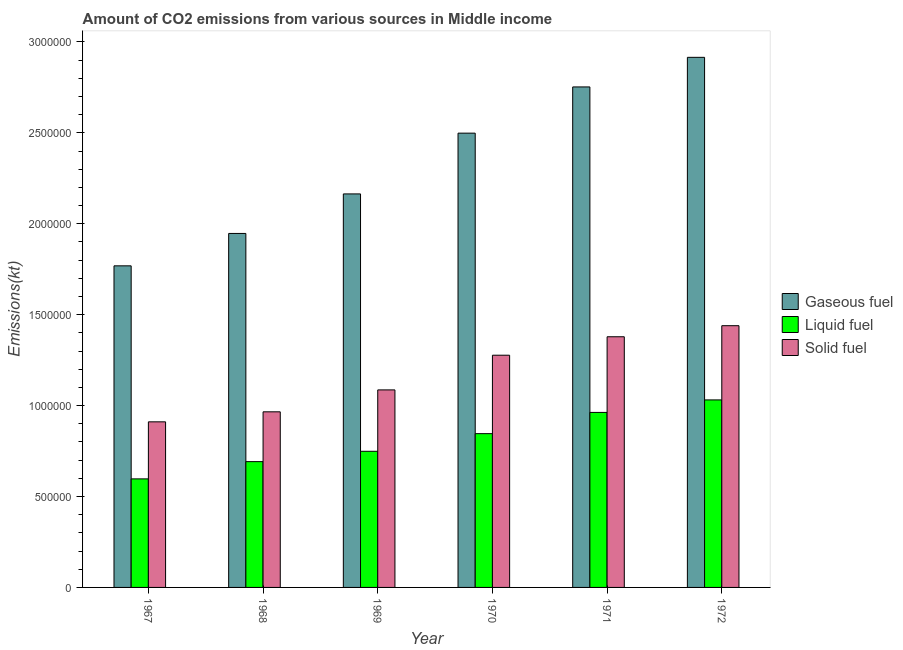How many bars are there on the 3rd tick from the left?
Make the answer very short. 3. How many bars are there on the 4th tick from the right?
Offer a terse response. 3. What is the label of the 1st group of bars from the left?
Your response must be concise. 1967. What is the amount of co2 emissions from liquid fuel in 1968?
Keep it short and to the point. 6.92e+05. Across all years, what is the maximum amount of co2 emissions from gaseous fuel?
Keep it short and to the point. 2.92e+06. Across all years, what is the minimum amount of co2 emissions from gaseous fuel?
Your answer should be very brief. 1.77e+06. In which year was the amount of co2 emissions from gaseous fuel maximum?
Ensure brevity in your answer.  1972. In which year was the amount of co2 emissions from solid fuel minimum?
Make the answer very short. 1967. What is the total amount of co2 emissions from solid fuel in the graph?
Provide a succinct answer. 7.06e+06. What is the difference between the amount of co2 emissions from gaseous fuel in 1968 and that in 1969?
Keep it short and to the point. -2.17e+05. What is the difference between the amount of co2 emissions from solid fuel in 1968 and the amount of co2 emissions from gaseous fuel in 1972?
Provide a succinct answer. -4.74e+05. What is the average amount of co2 emissions from gaseous fuel per year?
Your answer should be very brief. 2.34e+06. In the year 1969, what is the difference between the amount of co2 emissions from solid fuel and amount of co2 emissions from liquid fuel?
Give a very brief answer. 0. In how many years, is the amount of co2 emissions from liquid fuel greater than 2800000 kt?
Your answer should be very brief. 0. What is the ratio of the amount of co2 emissions from solid fuel in 1967 to that in 1972?
Your response must be concise. 0.63. Is the amount of co2 emissions from solid fuel in 1967 less than that in 1972?
Keep it short and to the point. Yes. Is the difference between the amount of co2 emissions from gaseous fuel in 1967 and 1971 greater than the difference between the amount of co2 emissions from liquid fuel in 1967 and 1971?
Offer a terse response. No. What is the difference between the highest and the second highest amount of co2 emissions from liquid fuel?
Make the answer very short. 6.87e+04. What is the difference between the highest and the lowest amount of co2 emissions from liquid fuel?
Make the answer very short. 4.34e+05. Is the sum of the amount of co2 emissions from gaseous fuel in 1967 and 1972 greater than the maximum amount of co2 emissions from solid fuel across all years?
Your answer should be very brief. Yes. What does the 3rd bar from the left in 1969 represents?
Keep it short and to the point. Solid fuel. What does the 1st bar from the right in 1967 represents?
Your answer should be very brief. Solid fuel. Is it the case that in every year, the sum of the amount of co2 emissions from gaseous fuel and amount of co2 emissions from liquid fuel is greater than the amount of co2 emissions from solid fuel?
Make the answer very short. Yes. Are all the bars in the graph horizontal?
Your answer should be compact. No. Does the graph contain any zero values?
Ensure brevity in your answer.  No. Does the graph contain grids?
Give a very brief answer. No. Where does the legend appear in the graph?
Provide a succinct answer. Center right. How many legend labels are there?
Provide a succinct answer. 3. What is the title of the graph?
Ensure brevity in your answer.  Amount of CO2 emissions from various sources in Middle income. What is the label or title of the X-axis?
Offer a very short reply. Year. What is the label or title of the Y-axis?
Give a very brief answer. Emissions(kt). What is the Emissions(kt) of Gaseous fuel in 1967?
Keep it short and to the point. 1.77e+06. What is the Emissions(kt) in Liquid fuel in 1967?
Your answer should be compact. 5.97e+05. What is the Emissions(kt) in Solid fuel in 1967?
Ensure brevity in your answer.  9.11e+05. What is the Emissions(kt) in Gaseous fuel in 1968?
Your answer should be very brief. 1.95e+06. What is the Emissions(kt) of Liquid fuel in 1968?
Give a very brief answer. 6.92e+05. What is the Emissions(kt) of Solid fuel in 1968?
Offer a very short reply. 9.66e+05. What is the Emissions(kt) of Gaseous fuel in 1969?
Provide a short and direct response. 2.16e+06. What is the Emissions(kt) in Liquid fuel in 1969?
Make the answer very short. 7.49e+05. What is the Emissions(kt) in Solid fuel in 1969?
Provide a succinct answer. 1.09e+06. What is the Emissions(kt) of Gaseous fuel in 1970?
Provide a short and direct response. 2.50e+06. What is the Emissions(kt) of Liquid fuel in 1970?
Ensure brevity in your answer.  8.46e+05. What is the Emissions(kt) of Solid fuel in 1970?
Your answer should be compact. 1.28e+06. What is the Emissions(kt) of Gaseous fuel in 1971?
Your answer should be very brief. 2.75e+06. What is the Emissions(kt) in Liquid fuel in 1971?
Provide a succinct answer. 9.62e+05. What is the Emissions(kt) in Solid fuel in 1971?
Give a very brief answer. 1.38e+06. What is the Emissions(kt) of Gaseous fuel in 1972?
Offer a terse response. 2.92e+06. What is the Emissions(kt) of Liquid fuel in 1972?
Offer a very short reply. 1.03e+06. What is the Emissions(kt) of Solid fuel in 1972?
Give a very brief answer. 1.44e+06. Across all years, what is the maximum Emissions(kt) in Gaseous fuel?
Give a very brief answer. 2.92e+06. Across all years, what is the maximum Emissions(kt) of Liquid fuel?
Your answer should be compact. 1.03e+06. Across all years, what is the maximum Emissions(kt) in Solid fuel?
Give a very brief answer. 1.44e+06. Across all years, what is the minimum Emissions(kt) of Gaseous fuel?
Ensure brevity in your answer.  1.77e+06. Across all years, what is the minimum Emissions(kt) in Liquid fuel?
Offer a terse response. 5.97e+05. Across all years, what is the minimum Emissions(kt) in Solid fuel?
Your answer should be compact. 9.11e+05. What is the total Emissions(kt) in Gaseous fuel in the graph?
Provide a short and direct response. 1.40e+07. What is the total Emissions(kt) in Liquid fuel in the graph?
Your answer should be compact. 4.88e+06. What is the total Emissions(kt) of Solid fuel in the graph?
Keep it short and to the point. 7.06e+06. What is the difference between the Emissions(kt) of Gaseous fuel in 1967 and that in 1968?
Your answer should be very brief. -1.78e+05. What is the difference between the Emissions(kt) in Liquid fuel in 1967 and that in 1968?
Provide a succinct answer. -9.49e+04. What is the difference between the Emissions(kt) of Solid fuel in 1967 and that in 1968?
Ensure brevity in your answer.  -5.51e+04. What is the difference between the Emissions(kt) in Gaseous fuel in 1967 and that in 1969?
Your response must be concise. -3.95e+05. What is the difference between the Emissions(kt) in Liquid fuel in 1967 and that in 1969?
Your answer should be very brief. -1.52e+05. What is the difference between the Emissions(kt) of Solid fuel in 1967 and that in 1969?
Your response must be concise. -1.76e+05. What is the difference between the Emissions(kt) of Gaseous fuel in 1967 and that in 1970?
Your response must be concise. -7.30e+05. What is the difference between the Emissions(kt) of Liquid fuel in 1967 and that in 1970?
Ensure brevity in your answer.  -2.49e+05. What is the difference between the Emissions(kt) of Solid fuel in 1967 and that in 1970?
Your response must be concise. -3.66e+05. What is the difference between the Emissions(kt) of Gaseous fuel in 1967 and that in 1971?
Your response must be concise. -9.84e+05. What is the difference between the Emissions(kt) in Liquid fuel in 1967 and that in 1971?
Ensure brevity in your answer.  -3.66e+05. What is the difference between the Emissions(kt) in Solid fuel in 1967 and that in 1971?
Ensure brevity in your answer.  -4.68e+05. What is the difference between the Emissions(kt) of Gaseous fuel in 1967 and that in 1972?
Make the answer very short. -1.15e+06. What is the difference between the Emissions(kt) in Liquid fuel in 1967 and that in 1972?
Your response must be concise. -4.34e+05. What is the difference between the Emissions(kt) in Solid fuel in 1967 and that in 1972?
Offer a very short reply. -5.29e+05. What is the difference between the Emissions(kt) in Gaseous fuel in 1968 and that in 1969?
Make the answer very short. -2.17e+05. What is the difference between the Emissions(kt) in Liquid fuel in 1968 and that in 1969?
Ensure brevity in your answer.  -5.69e+04. What is the difference between the Emissions(kt) of Solid fuel in 1968 and that in 1969?
Keep it short and to the point. -1.21e+05. What is the difference between the Emissions(kt) in Gaseous fuel in 1968 and that in 1970?
Ensure brevity in your answer.  -5.52e+05. What is the difference between the Emissions(kt) in Liquid fuel in 1968 and that in 1970?
Provide a succinct answer. -1.54e+05. What is the difference between the Emissions(kt) of Solid fuel in 1968 and that in 1970?
Ensure brevity in your answer.  -3.11e+05. What is the difference between the Emissions(kt) in Gaseous fuel in 1968 and that in 1971?
Offer a terse response. -8.06e+05. What is the difference between the Emissions(kt) of Liquid fuel in 1968 and that in 1971?
Offer a terse response. -2.71e+05. What is the difference between the Emissions(kt) in Solid fuel in 1968 and that in 1971?
Your answer should be very brief. -4.13e+05. What is the difference between the Emissions(kt) in Gaseous fuel in 1968 and that in 1972?
Ensure brevity in your answer.  -9.69e+05. What is the difference between the Emissions(kt) of Liquid fuel in 1968 and that in 1972?
Make the answer very short. -3.39e+05. What is the difference between the Emissions(kt) in Solid fuel in 1968 and that in 1972?
Your response must be concise. -4.74e+05. What is the difference between the Emissions(kt) of Gaseous fuel in 1969 and that in 1970?
Keep it short and to the point. -3.34e+05. What is the difference between the Emissions(kt) in Liquid fuel in 1969 and that in 1970?
Provide a succinct answer. -9.70e+04. What is the difference between the Emissions(kt) in Solid fuel in 1969 and that in 1970?
Keep it short and to the point. -1.91e+05. What is the difference between the Emissions(kt) of Gaseous fuel in 1969 and that in 1971?
Ensure brevity in your answer.  -5.88e+05. What is the difference between the Emissions(kt) of Liquid fuel in 1969 and that in 1971?
Provide a short and direct response. -2.14e+05. What is the difference between the Emissions(kt) in Solid fuel in 1969 and that in 1971?
Offer a very short reply. -2.92e+05. What is the difference between the Emissions(kt) of Gaseous fuel in 1969 and that in 1972?
Give a very brief answer. -7.51e+05. What is the difference between the Emissions(kt) of Liquid fuel in 1969 and that in 1972?
Your answer should be compact. -2.83e+05. What is the difference between the Emissions(kt) in Solid fuel in 1969 and that in 1972?
Your response must be concise. -3.53e+05. What is the difference between the Emissions(kt) in Gaseous fuel in 1970 and that in 1971?
Make the answer very short. -2.54e+05. What is the difference between the Emissions(kt) in Liquid fuel in 1970 and that in 1971?
Provide a succinct answer. -1.17e+05. What is the difference between the Emissions(kt) of Solid fuel in 1970 and that in 1971?
Your answer should be very brief. -1.01e+05. What is the difference between the Emissions(kt) in Gaseous fuel in 1970 and that in 1972?
Offer a very short reply. -4.17e+05. What is the difference between the Emissions(kt) in Liquid fuel in 1970 and that in 1972?
Provide a short and direct response. -1.85e+05. What is the difference between the Emissions(kt) in Solid fuel in 1970 and that in 1972?
Make the answer very short. -1.62e+05. What is the difference between the Emissions(kt) in Gaseous fuel in 1971 and that in 1972?
Offer a terse response. -1.63e+05. What is the difference between the Emissions(kt) of Liquid fuel in 1971 and that in 1972?
Ensure brevity in your answer.  -6.87e+04. What is the difference between the Emissions(kt) of Solid fuel in 1971 and that in 1972?
Keep it short and to the point. -6.09e+04. What is the difference between the Emissions(kt) of Gaseous fuel in 1967 and the Emissions(kt) of Liquid fuel in 1968?
Make the answer very short. 1.08e+06. What is the difference between the Emissions(kt) of Gaseous fuel in 1967 and the Emissions(kt) of Solid fuel in 1968?
Offer a terse response. 8.03e+05. What is the difference between the Emissions(kt) in Liquid fuel in 1967 and the Emissions(kt) in Solid fuel in 1968?
Keep it short and to the point. -3.69e+05. What is the difference between the Emissions(kt) in Gaseous fuel in 1967 and the Emissions(kt) in Liquid fuel in 1969?
Your answer should be compact. 1.02e+06. What is the difference between the Emissions(kt) in Gaseous fuel in 1967 and the Emissions(kt) in Solid fuel in 1969?
Your answer should be very brief. 6.82e+05. What is the difference between the Emissions(kt) of Liquid fuel in 1967 and the Emissions(kt) of Solid fuel in 1969?
Your response must be concise. -4.89e+05. What is the difference between the Emissions(kt) in Gaseous fuel in 1967 and the Emissions(kt) in Liquid fuel in 1970?
Offer a terse response. 9.23e+05. What is the difference between the Emissions(kt) of Gaseous fuel in 1967 and the Emissions(kt) of Solid fuel in 1970?
Your answer should be compact. 4.92e+05. What is the difference between the Emissions(kt) of Liquid fuel in 1967 and the Emissions(kt) of Solid fuel in 1970?
Your answer should be very brief. -6.80e+05. What is the difference between the Emissions(kt) of Gaseous fuel in 1967 and the Emissions(kt) of Liquid fuel in 1971?
Your answer should be very brief. 8.06e+05. What is the difference between the Emissions(kt) of Gaseous fuel in 1967 and the Emissions(kt) of Solid fuel in 1971?
Your answer should be compact. 3.90e+05. What is the difference between the Emissions(kt) in Liquid fuel in 1967 and the Emissions(kt) in Solid fuel in 1971?
Your response must be concise. -7.82e+05. What is the difference between the Emissions(kt) of Gaseous fuel in 1967 and the Emissions(kt) of Liquid fuel in 1972?
Provide a short and direct response. 7.37e+05. What is the difference between the Emissions(kt) in Gaseous fuel in 1967 and the Emissions(kt) in Solid fuel in 1972?
Make the answer very short. 3.29e+05. What is the difference between the Emissions(kt) of Liquid fuel in 1967 and the Emissions(kt) of Solid fuel in 1972?
Provide a short and direct response. -8.42e+05. What is the difference between the Emissions(kt) in Gaseous fuel in 1968 and the Emissions(kt) in Liquid fuel in 1969?
Offer a terse response. 1.20e+06. What is the difference between the Emissions(kt) of Gaseous fuel in 1968 and the Emissions(kt) of Solid fuel in 1969?
Your response must be concise. 8.60e+05. What is the difference between the Emissions(kt) in Liquid fuel in 1968 and the Emissions(kt) in Solid fuel in 1969?
Your answer should be very brief. -3.94e+05. What is the difference between the Emissions(kt) in Gaseous fuel in 1968 and the Emissions(kt) in Liquid fuel in 1970?
Keep it short and to the point. 1.10e+06. What is the difference between the Emissions(kt) in Gaseous fuel in 1968 and the Emissions(kt) in Solid fuel in 1970?
Your answer should be compact. 6.70e+05. What is the difference between the Emissions(kt) of Liquid fuel in 1968 and the Emissions(kt) of Solid fuel in 1970?
Offer a very short reply. -5.85e+05. What is the difference between the Emissions(kt) in Gaseous fuel in 1968 and the Emissions(kt) in Liquid fuel in 1971?
Your response must be concise. 9.84e+05. What is the difference between the Emissions(kt) in Gaseous fuel in 1968 and the Emissions(kt) in Solid fuel in 1971?
Offer a very short reply. 5.68e+05. What is the difference between the Emissions(kt) in Liquid fuel in 1968 and the Emissions(kt) in Solid fuel in 1971?
Your response must be concise. -6.87e+05. What is the difference between the Emissions(kt) in Gaseous fuel in 1968 and the Emissions(kt) in Liquid fuel in 1972?
Offer a terse response. 9.15e+05. What is the difference between the Emissions(kt) of Gaseous fuel in 1968 and the Emissions(kt) of Solid fuel in 1972?
Provide a succinct answer. 5.07e+05. What is the difference between the Emissions(kt) of Liquid fuel in 1968 and the Emissions(kt) of Solid fuel in 1972?
Your answer should be very brief. -7.48e+05. What is the difference between the Emissions(kt) of Gaseous fuel in 1969 and the Emissions(kt) of Liquid fuel in 1970?
Keep it short and to the point. 1.32e+06. What is the difference between the Emissions(kt) in Gaseous fuel in 1969 and the Emissions(kt) in Solid fuel in 1970?
Ensure brevity in your answer.  8.87e+05. What is the difference between the Emissions(kt) of Liquid fuel in 1969 and the Emissions(kt) of Solid fuel in 1970?
Your answer should be very brief. -5.28e+05. What is the difference between the Emissions(kt) in Gaseous fuel in 1969 and the Emissions(kt) in Liquid fuel in 1971?
Ensure brevity in your answer.  1.20e+06. What is the difference between the Emissions(kt) in Gaseous fuel in 1969 and the Emissions(kt) in Solid fuel in 1971?
Make the answer very short. 7.86e+05. What is the difference between the Emissions(kt) of Liquid fuel in 1969 and the Emissions(kt) of Solid fuel in 1971?
Provide a succinct answer. -6.30e+05. What is the difference between the Emissions(kt) of Gaseous fuel in 1969 and the Emissions(kt) of Liquid fuel in 1972?
Your answer should be compact. 1.13e+06. What is the difference between the Emissions(kt) of Gaseous fuel in 1969 and the Emissions(kt) of Solid fuel in 1972?
Offer a terse response. 7.25e+05. What is the difference between the Emissions(kt) of Liquid fuel in 1969 and the Emissions(kt) of Solid fuel in 1972?
Provide a short and direct response. -6.91e+05. What is the difference between the Emissions(kt) in Gaseous fuel in 1970 and the Emissions(kt) in Liquid fuel in 1971?
Ensure brevity in your answer.  1.54e+06. What is the difference between the Emissions(kt) in Gaseous fuel in 1970 and the Emissions(kt) in Solid fuel in 1971?
Your answer should be compact. 1.12e+06. What is the difference between the Emissions(kt) of Liquid fuel in 1970 and the Emissions(kt) of Solid fuel in 1971?
Provide a short and direct response. -5.33e+05. What is the difference between the Emissions(kt) of Gaseous fuel in 1970 and the Emissions(kt) of Liquid fuel in 1972?
Provide a short and direct response. 1.47e+06. What is the difference between the Emissions(kt) in Gaseous fuel in 1970 and the Emissions(kt) in Solid fuel in 1972?
Give a very brief answer. 1.06e+06. What is the difference between the Emissions(kt) in Liquid fuel in 1970 and the Emissions(kt) in Solid fuel in 1972?
Offer a very short reply. -5.94e+05. What is the difference between the Emissions(kt) in Gaseous fuel in 1971 and the Emissions(kt) in Liquid fuel in 1972?
Offer a very short reply. 1.72e+06. What is the difference between the Emissions(kt) of Gaseous fuel in 1971 and the Emissions(kt) of Solid fuel in 1972?
Offer a very short reply. 1.31e+06. What is the difference between the Emissions(kt) in Liquid fuel in 1971 and the Emissions(kt) in Solid fuel in 1972?
Offer a terse response. -4.77e+05. What is the average Emissions(kt) in Gaseous fuel per year?
Make the answer very short. 2.34e+06. What is the average Emissions(kt) of Liquid fuel per year?
Offer a very short reply. 8.13e+05. What is the average Emissions(kt) in Solid fuel per year?
Provide a short and direct response. 1.18e+06. In the year 1967, what is the difference between the Emissions(kt) of Gaseous fuel and Emissions(kt) of Liquid fuel?
Keep it short and to the point. 1.17e+06. In the year 1967, what is the difference between the Emissions(kt) in Gaseous fuel and Emissions(kt) in Solid fuel?
Give a very brief answer. 8.58e+05. In the year 1967, what is the difference between the Emissions(kt) of Liquid fuel and Emissions(kt) of Solid fuel?
Your answer should be very brief. -3.14e+05. In the year 1968, what is the difference between the Emissions(kt) in Gaseous fuel and Emissions(kt) in Liquid fuel?
Offer a terse response. 1.25e+06. In the year 1968, what is the difference between the Emissions(kt) of Gaseous fuel and Emissions(kt) of Solid fuel?
Provide a succinct answer. 9.81e+05. In the year 1968, what is the difference between the Emissions(kt) in Liquid fuel and Emissions(kt) in Solid fuel?
Make the answer very short. -2.74e+05. In the year 1969, what is the difference between the Emissions(kt) of Gaseous fuel and Emissions(kt) of Liquid fuel?
Make the answer very short. 1.42e+06. In the year 1969, what is the difference between the Emissions(kt) in Gaseous fuel and Emissions(kt) in Solid fuel?
Your answer should be very brief. 1.08e+06. In the year 1969, what is the difference between the Emissions(kt) in Liquid fuel and Emissions(kt) in Solid fuel?
Provide a short and direct response. -3.38e+05. In the year 1970, what is the difference between the Emissions(kt) in Gaseous fuel and Emissions(kt) in Liquid fuel?
Your response must be concise. 1.65e+06. In the year 1970, what is the difference between the Emissions(kt) in Gaseous fuel and Emissions(kt) in Solid fuel?
Provide a short and direct response. 1.22e+06. In the year 1970, what is the difference between the Emissions(kt) in Liquid fuel and Emissions(kt) in Solid fuel?
Ensure brevity in your answer.  -4.31e+05. In the year 1971, what is the difference between the Emissions(kt) of Gaseous fuel and Emissions(kt) of Liquid fuel?
Your answer should be very brief. 1.79e+06. In the year 1971, what is the difference between the Emissions(kt) of Gaseous fuel and Emissions(kt) of Solid fuel?
Offer a very short reply. 1.37e+06. In the year 1971, what is the difference between the Emissions(kt) in Liquid fuel and Emissions(kt) in Solid fuel?
Ensure brevity in your answer.  -4.16e+05. In the year 1972, what is the difference between the Emissions(kt) in Gaseous fuel and Emissions(kt) in Liquid fuel?
Your answer should be compact. 1.88e+06. In the year 1972, what is the difference between the Emissions(kt) in Gaseous fuel and Emissions(kt) in Solid fuel?
Make the answer very short. 1.48e+06. In the year 1972, what is the difference between the Emissions(kt) in Liquid fuel and Emissions(kt) in Solid fuel?
Your answer should be very brief. -4.08e+05. What is the ratio of the Emissions(kt) of Gaseous fuel in 1967 to that in 1968?
Ensure brevity in your answer.  0.91. What is the ratio of the Emissions(kt) in Liquid fuel in 1967 to that in 1968?
Ensure brevity in your answer.  0.86. What is the ratio of the Emissions(kt) of Solid fuel in 1967 to that in 1968?
Keep it short and to the point. 0.94. What is the ratio of the Emissions(kt) in Gaseous fuel in 1967 to that in 1969?
Your answer should be compact. 0.82. What is the ratio of the Emissions(kt) of Liquid fuel in 1967 to that in 1969?
Your answer should be compact. 0.8. What is the ratio of the Emissions(kt) of Solid fuel in 1967 to that in 1969?
Your answer should be very brief. 0.84. What is the ratio of the Emissions(kt) of Gaseous fuel in 1967 to that in 1970?
Your response must be concise. 0.71. What is the ratio of the Emissions(kt) of Liquid fuel in 1967 to that in 1970?
Provide a succinct answer. 0.71. What is the ratio of the Emissions(kt) of Solid fuel in 1967 to that in 1970?
Your answer should be compact. 0.71. What is the ratio of the Emissions(kt) in Gaseous fuel in 1967 to that in 1971?
Provide a succinct answer. 0.64. What is the ratio of the Emissions(kt) of Liquid fuel in 1967 to that in 1971?
Ensure brevity in your answer.  0.62. What is the ratio of the Emissions(kt) of Solid fuel in 1967 to that in 1971?
Your response must be concise. 0.66. What is the ratio of the Emissions(kt) in Gaseous fuel in 1967 to that in 1972?
Keep it short and to the point. 0.61. What is the ratio of the Emissions(kt) in Liquid fuel in 1967 to that in 1972?
Make the answer very short. 0.58. What is the ratio of the Emissions(kt) of Solid fuel in 1967 to that in 1972?
Make the answer very short. 0.63. What is the ratio of the Emissions(kt) of Gaseous fuel in 1968 to that in 1969?
Make the answer very short. 0.9. What is the ratio of the Emissions(kt) in Liquid fuel in 1968 to that in 1969?
Your response must be concise. 0.92. What is the ratio of the Emissions(kt) of Solid fuel in 1968 to that in 1969?
Provide a short and direct response. 0.89. What is the ratio of the Emissions(kt) in Gaseous fuel in 1968 to that in 1970?
Make the answer very short. 0.78. What is the ratio of the Emissions(kt) of Liquid fuel in 1968 to that in 1970?
Give a very brief answer. 0.82. What is the ratio of the Emissions(kt) in Solid fuel in 1968 to that in 1970?
Give a very brief answer. 0.76. What is the ratio of the Emissions(kt) of Gaseous fuel in 1968 to that in 1971?
Provide a short and direct response. 0.71. What is the ratio of the Emissions(kt) of Liquid fuel in 1968 to that in 1971?
Provide a short and direct response. 0.72. What is the ratio of the Emissions(kt) in Solid fuel in 1968 to that in 1971?
Your response must be concise. 0.7. What is the ratio of the Emissions(kt) in Gaseous fuel in 1968 to that in 1972?
Provide a succinct answer. 0.67. What is the ratio of the Emissions(kt) of Liquid fuel in 1968 to that in 1972?
Your answer should be compact. 0.67. What is the ratio of the Emissions(kt) in Solid fuel in 1968 to that in 1972?
Offer a terse response. 0.67. What is the ratio of the Emissions(kt) in Gaseous fuel in 1969 to that in 1970?
Your response must be concise. 0.87. What is the ratio of the Emissions(kt) in Liquid fuel in 1969 to that in 1970?
Make the answer very short. 0.89. What is the ratio of the Emissions(kt) in Solid fuel in 1969 to that in 1970?
Offer a terse response. 0.85. What is the ratio of the Emissions(kt) in Gaseous fuel in 1969 to that in 1971?
Offer a terse response. 0.79. What is the ratio of the Emissions(kt) of Liquid fuel in 1969 to that in 1971?
Your answer should be compact. 0.78. What is the ratio of the Emissions(kt) in Solid fuel in 1969 to that in 1971?
Keep it short and to the point. 0.79. What is the ratio of the Emissions(kt) in Gaseous fuel in 1969 to that in 1972?
Keep it short and to the point. 0.74. What is the ratio of the Emissions(kt) of Liquid fuel in 1969 to that in 1972?
Make the answer very short. 0.73. What is the ratio of the Emissions(kt) in Solid fuel in 1969 to that in 1972?
Offer a terse response. 0.75. What is the ratio of the Emissions(kt) of Gaseous fuel in 1970 to that in 1971?
Offer a very short reply. 0.91. What is the ratio of the Emissions(kt) of Liquid fuel in 1970 to that in 1971?
Give a very brief answer. 0.88. What is the ratio of the Emissions(kt) in Solid fuel in 1970 to that in 1971?
Ensure brevity in your answer.  0.93. What is the ratio of the Emissions(kt) in Gaseous fuel in 1970 to that in 1972?
Give a very brief answer. 0.86. What is the ratio of the Emissions(kt) of Liquid fuel in 1970 to that in 1972?
Offer a terse response. 0.82. What is the ratio of the Emissions(kt) in Solid fuel in 1970 to that in 1972?
Your answer should be very brief. 0.89. What is the ratio of the Emissions(kt) of Gaseous fuel in 1971 to that in 1972?
Offer a very short reply. 0.94. What is the ratio of the Emissions(kt) of Liquid fuel in 1971 to that in 1972?
Provide a succinct answer. 0.93. What is the ratio of the Emissions(kt) of Solid fuel in 1971 to that in 1972?
Give a very brief answer. 0.96. What is the difference between the highest and the second highest Emissions(kt) of Gaseous fuel?
Ensure brevity in your answer.  1.63e+05. What is the difference between the highest and the second highest Emissions(kt) in Liquid fuel?
Ensure brevity in your answer.  6.87e+04. What is the difference between the highest and the second highest Emissions(kt) in Solid fuel?
Make the answer very short. 6.09e+04. What is the difference between the highest and the lowest Emissions(kt) of Gaseous fuel?
Give a very brief answer. 1.15e+06. What is the difference between the highest and the lowest Emissions(kt) in Liquid fuel?
Make the answer very short. 4.34e+05. What is the difference between the highest and the lowest Emissions(kt) in Solid fuel?
Your response must be concise. 5.29e+05. 